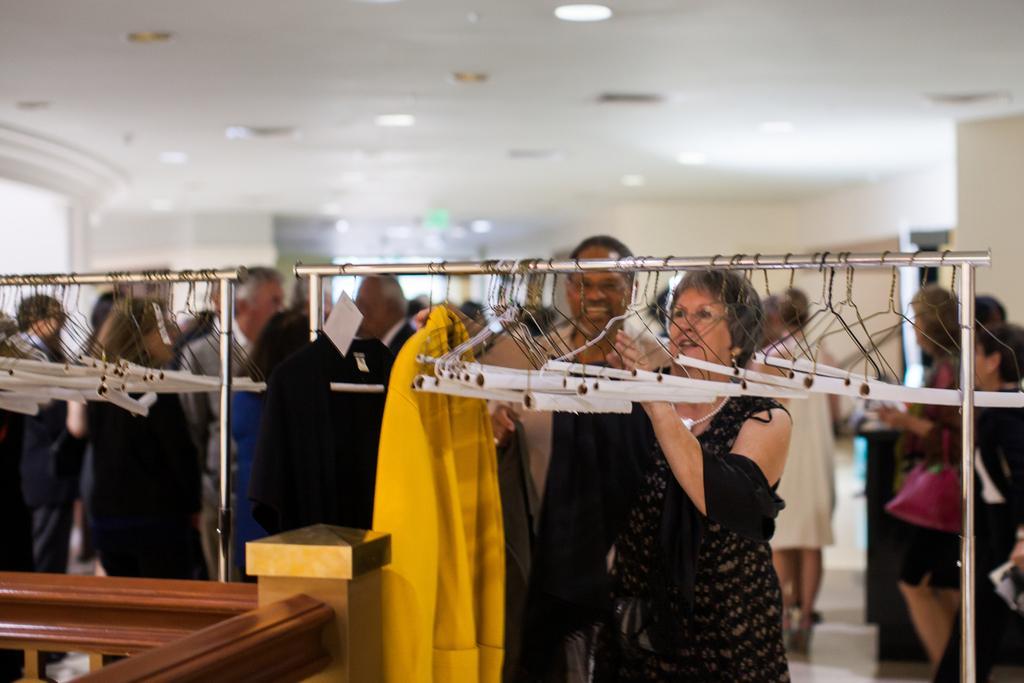How would you summarize this image in a sentence or two? In this image we can see hangers to the stand. At the bottom of the image we can see persons. In the background we can see persons, wall and lights. 